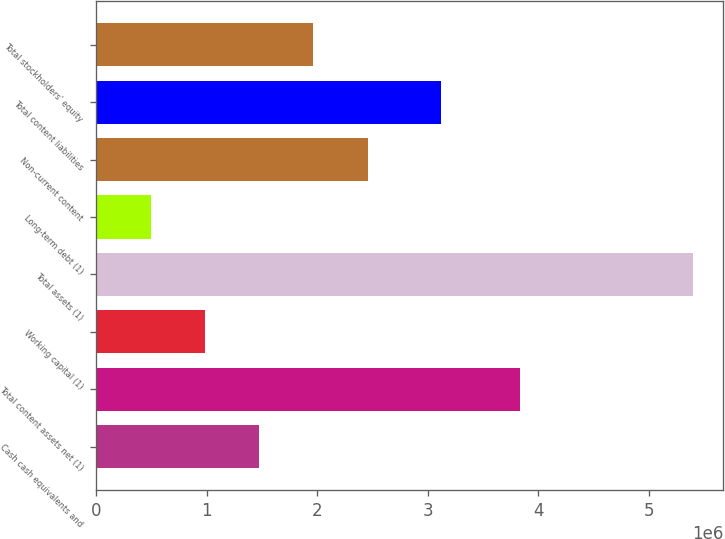Convert chart. <chart><loc_0><loc_0><loc_500><loc_500><bar_chart><fcel>Cash cash equivalents and<fcel>Total content assets net (1)<fcel>Working capital (1)<fcel>Total assets (1)<fcel>Long-term debt (1)<fcel>Non-current content<fcel>Total content liabilities<fcel>Total stockholders' equity<nl><fcel>1.47397e+06<fcel>3.83836e+06<fcel>982718<fcel>5.40402e+06<fcel>491462<fcel>2.45649e+06<fcel>3.12157e+06<fcel>1.96523e+06<nl></chart> 